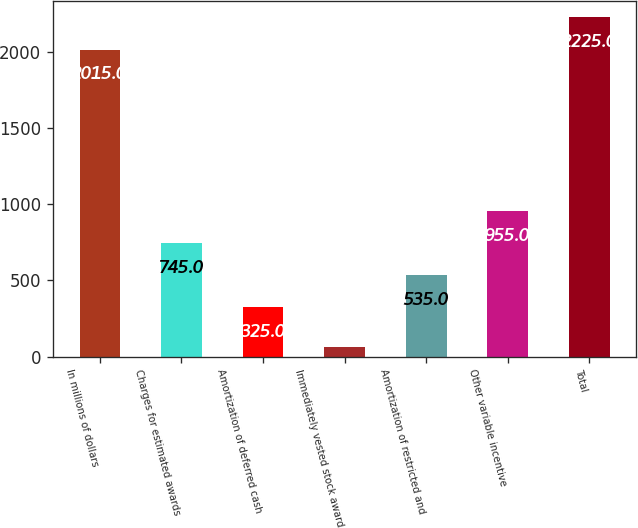<chart> <loc_0><loc_0><loc_500><loc_500><bar_chart><fcel>In millions of dollars<fcel>Charges for estimated awards<fcel>Amortization of deferred cash<fcel>Immediately vested stock award<fcel>Amortization of restricted and<fcel>Other variable incentive<fcel>Total<nl><fcel>2015<fcel>745<fcel>325<fcel>61<fcel>535<fcel>955<fcel>2225<nl></chart> 